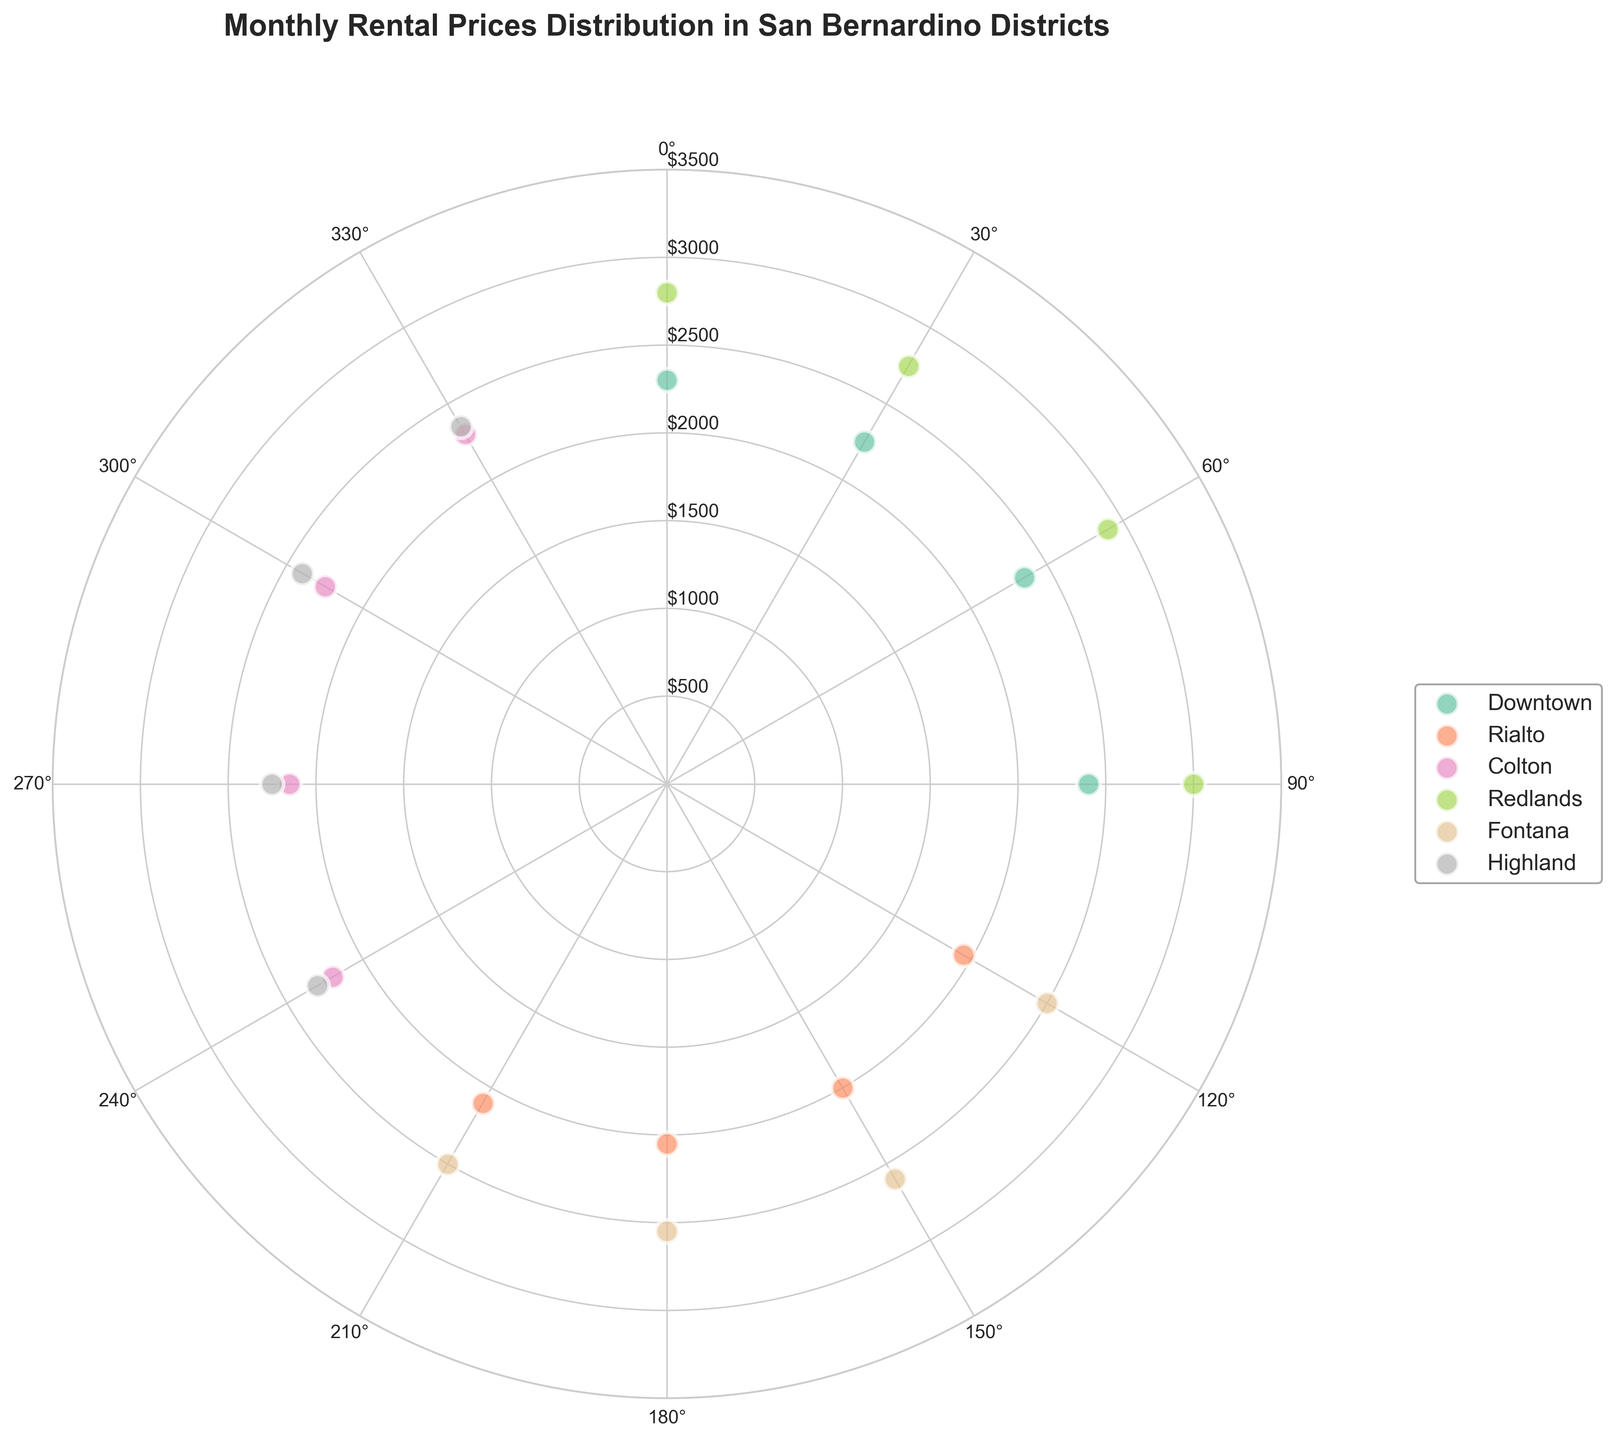What is the title of the chart? The title of the chart is typically displayed at the top center. In this chart, it's labeled "Monthly Rental Prices Distribution in San Bernardino Districts".
Answer: Monthly Rental Prices Distribution in San Bernardino Districts Which district has the highest rental price data point? From the colors representing different districts, look for the point with the maximum radius. Redlands has the highest value with a radius of $3000.
Answer: Redlands What is the range of rental prices for Downtown? By identifying the colored markers corresponding to Downtown, observe the vertical spread. The lowest data point is $2250 and the highest is $2400. The range is $2400 - $2250 = $150.
Answer: $150 Which district shows the greatest variability in prices? Variability can be estimated by observing the spread of radius values for each district. Fontana and Redlands show significant variability, with Redlands demonstrating a spread from $2750 to $3000, while Fontana varies from $2500 to $2600.
Answer: Redlands How many data points are there for Rialto? Count the number of scatter points that correspond to Rialto. Each district cluster is color-coded, and Rialto has 4 data points.
Answer: 4 What is the average rental price for Colton? Sum the rental prices for Colton and divide by the number of data points. Colton has prices of $2200, $2150, $2250, and $2300. The sum is $2200 + $2150 + $2250 + $2300 = $8900. The average is $8900 / 4 = $2225.
Answer: $2225 Which two districts have the overlapping rental price of $2300? Look for scatter points at a radius of $2300 and identify their colors. Both Downtown and Highland have points at $2300.
Answer: Downtown and Highland What is the median rental price for Fontana? List the rental prices for Fontana, order them and find the middle value. The prices are $2500, $2500, $2550, and $2600. The median is the average of the two middle values ($2500 and $2550), which is ($2500 + $2550) / 2 = $2525.
Answer: $2525 How does the distribution of rental prices in Highland compare to Downtown? Observe the scatter points for both districts. Highland's data points range from $2250 to $2400, whereas Downtown ranges from $2250 to $2400 as well, showing similar rental price distributions but distributed equally among different angles.
Answer: Similar distribution Which district appears to have the most consistent rental prices? Consistency can be interpreted as the smallest spread in data points. Rialto shows a small spread from $1950 to $2100, indicating consistent rental prices.
Answer: Rialto 